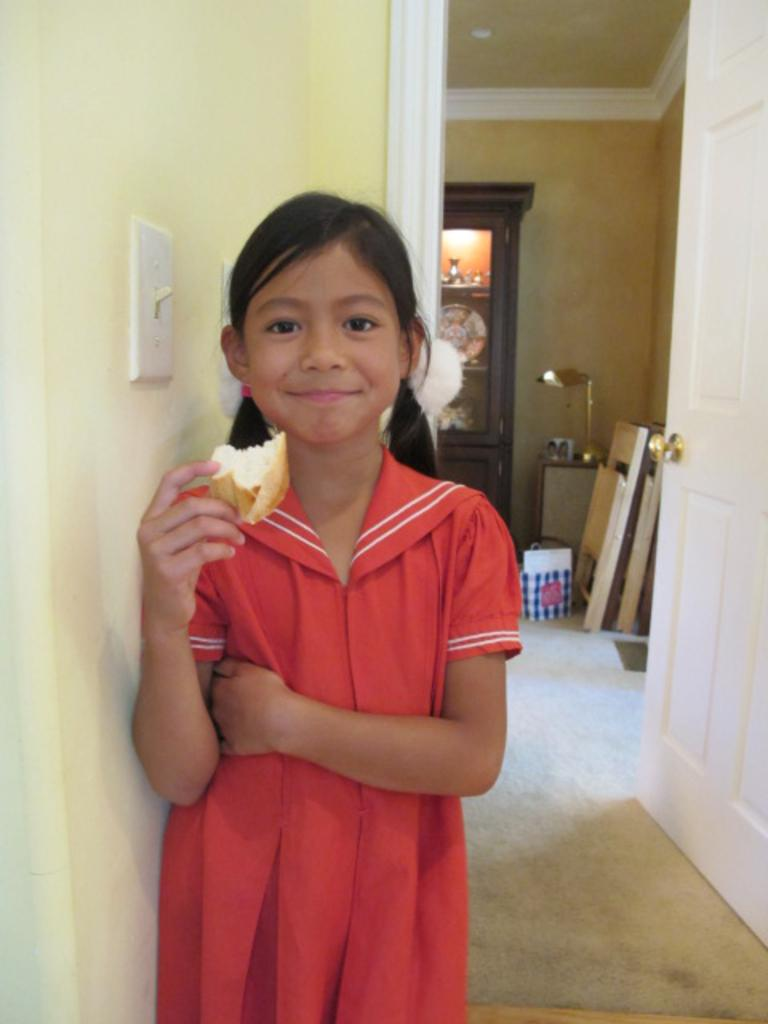Who is the main subject in the image? There is a girl in the image. What is the girl holding in the image? The girl is holding a bread. What is the girl's facial expression in the image? The girl is smiling. What can be seen behind the girl in the image? There is a bag visible behind the girl. What can be seen in the background of the image? There are lights and things in the racks in the background. What type of swing can be seen in the image? There is no swing present in the image. How many representatives are visible in the image? There is only one girl visible in the image, so there is no group or representative present. 